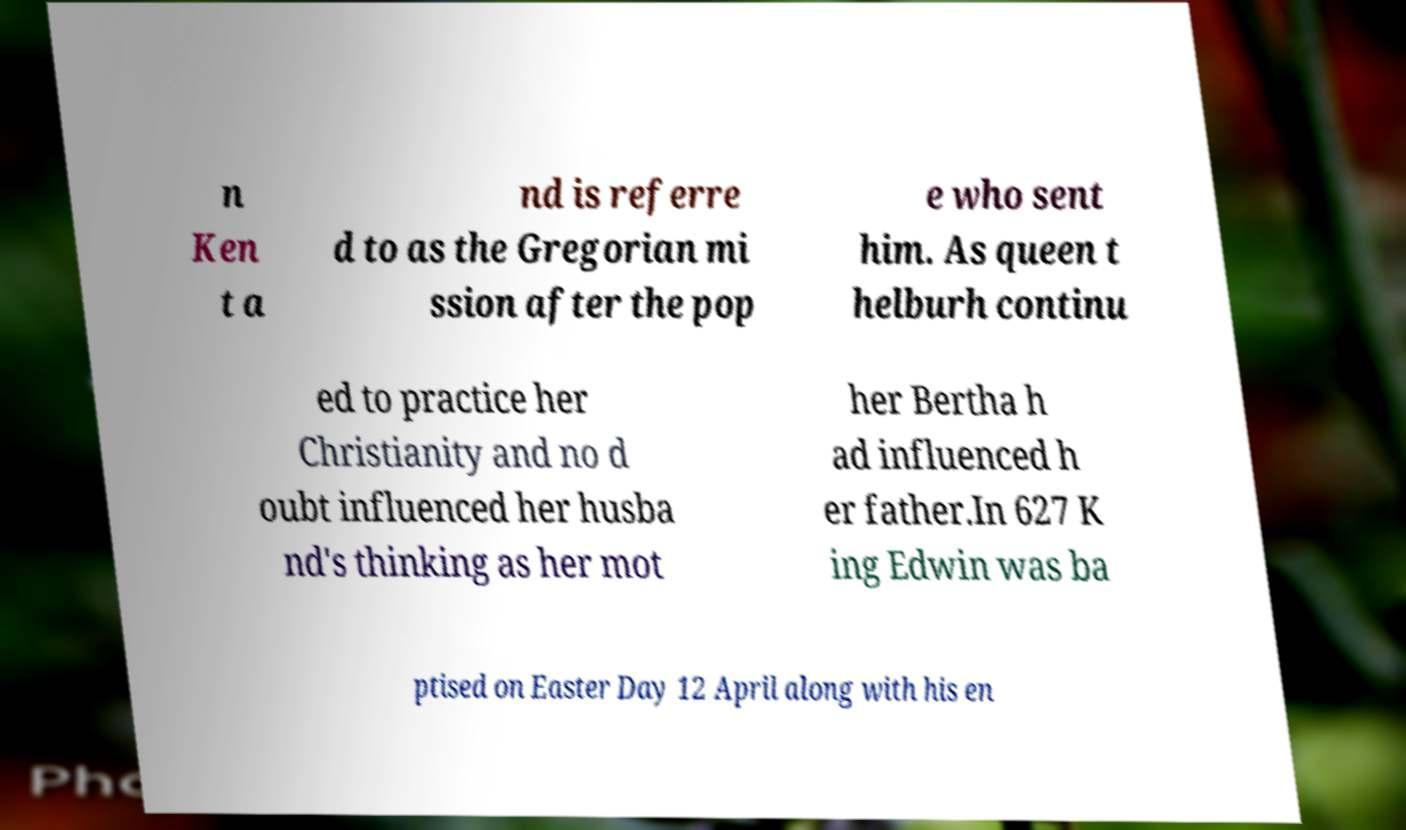I need the written content from this picture converted into text. Can you do that? n Ken t a nd is referre d to as the Gregorian mi ssion after the pop e who sent him. As queen t helburh continu ed to practice her Christianity and no d oubt influenced her husba nd's thinking as her mot her Bertha h ad influenced h er father.In 627 K ing Edwin was ba ptised on Easter Day 12 April along with his en 